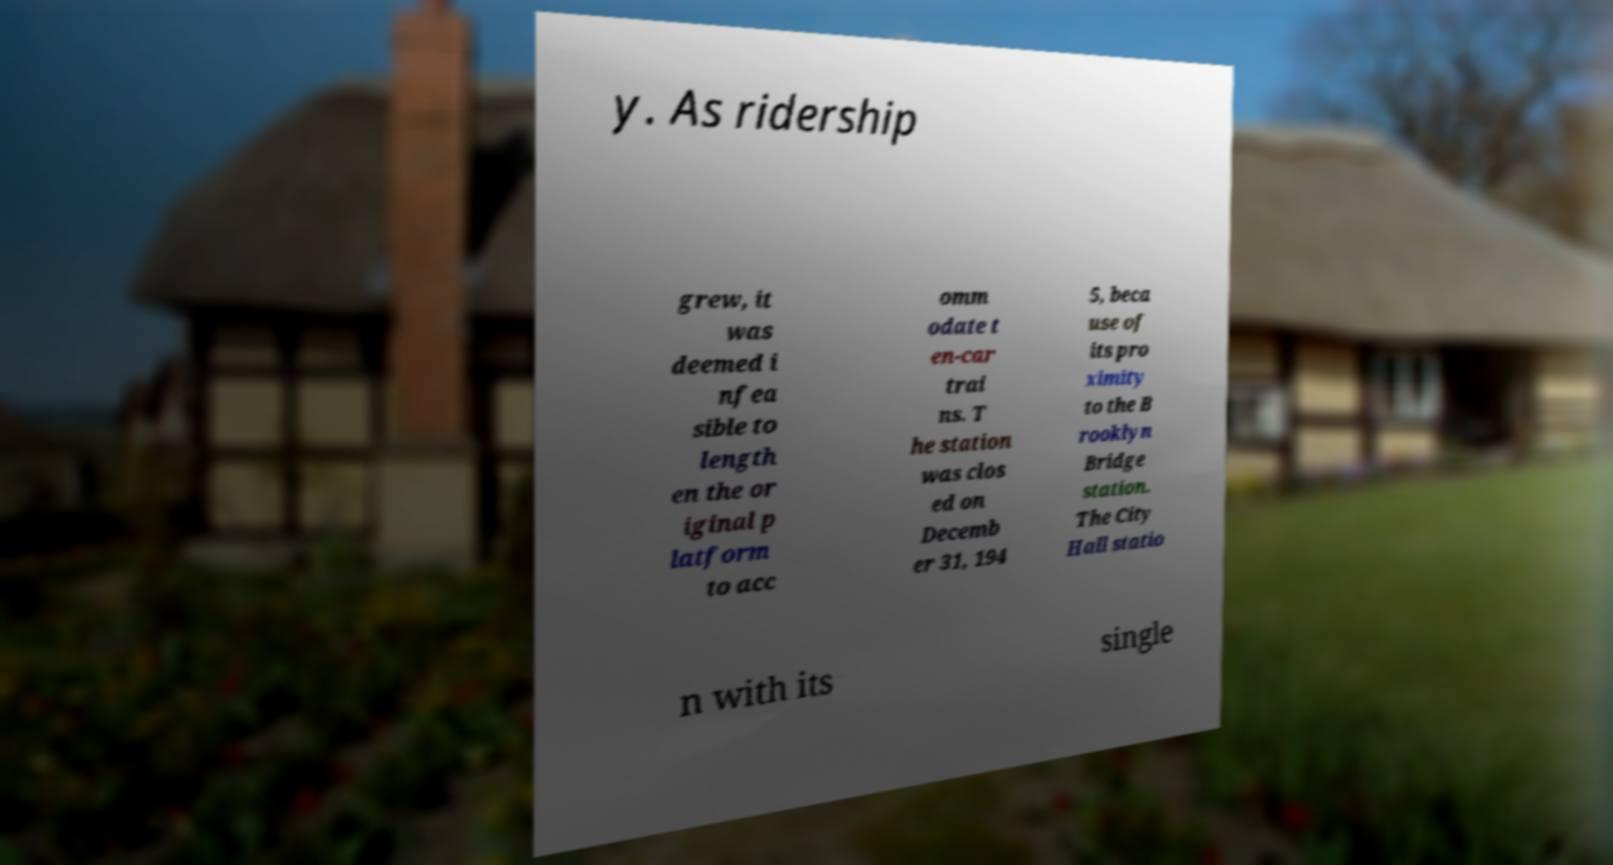Can you read and provide the text displayed in the image?This photo seems to have some interesting text. Can you extract and type it out for me? y. As ridership grew, it was deemed i nfea sible to length en the or iginal p latform to acc omm odate t en-car trai ns. T he station was clos ed on Decemb er 31, 194 5, beca use of its pro ximity to the B rooklyn Bridge station. The City Hall statio n with its single 